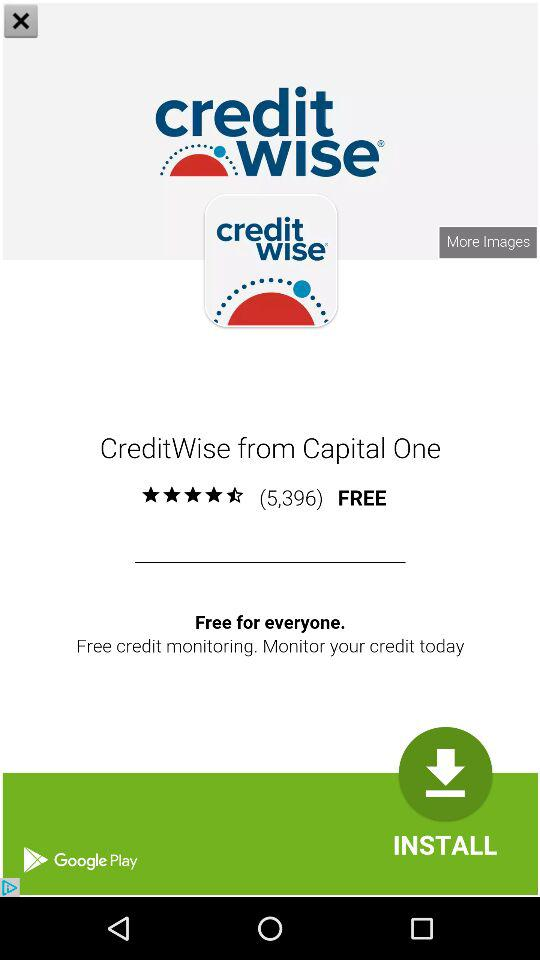What is the rating of the "CreditWise"? The rating is 4.5 stars. 